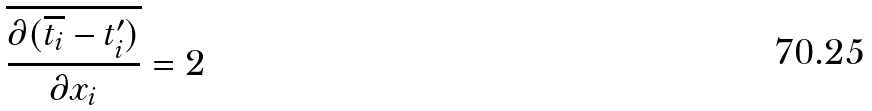Convert formula to latex. <formula><loc_0><loc_0><loc_500><loc_500>\overline { \frac { \partial ( \overline { t _ { i } } - t _ { i } ^ { \prime } ) } { \partial x _ { i } } } = 2</formula> 